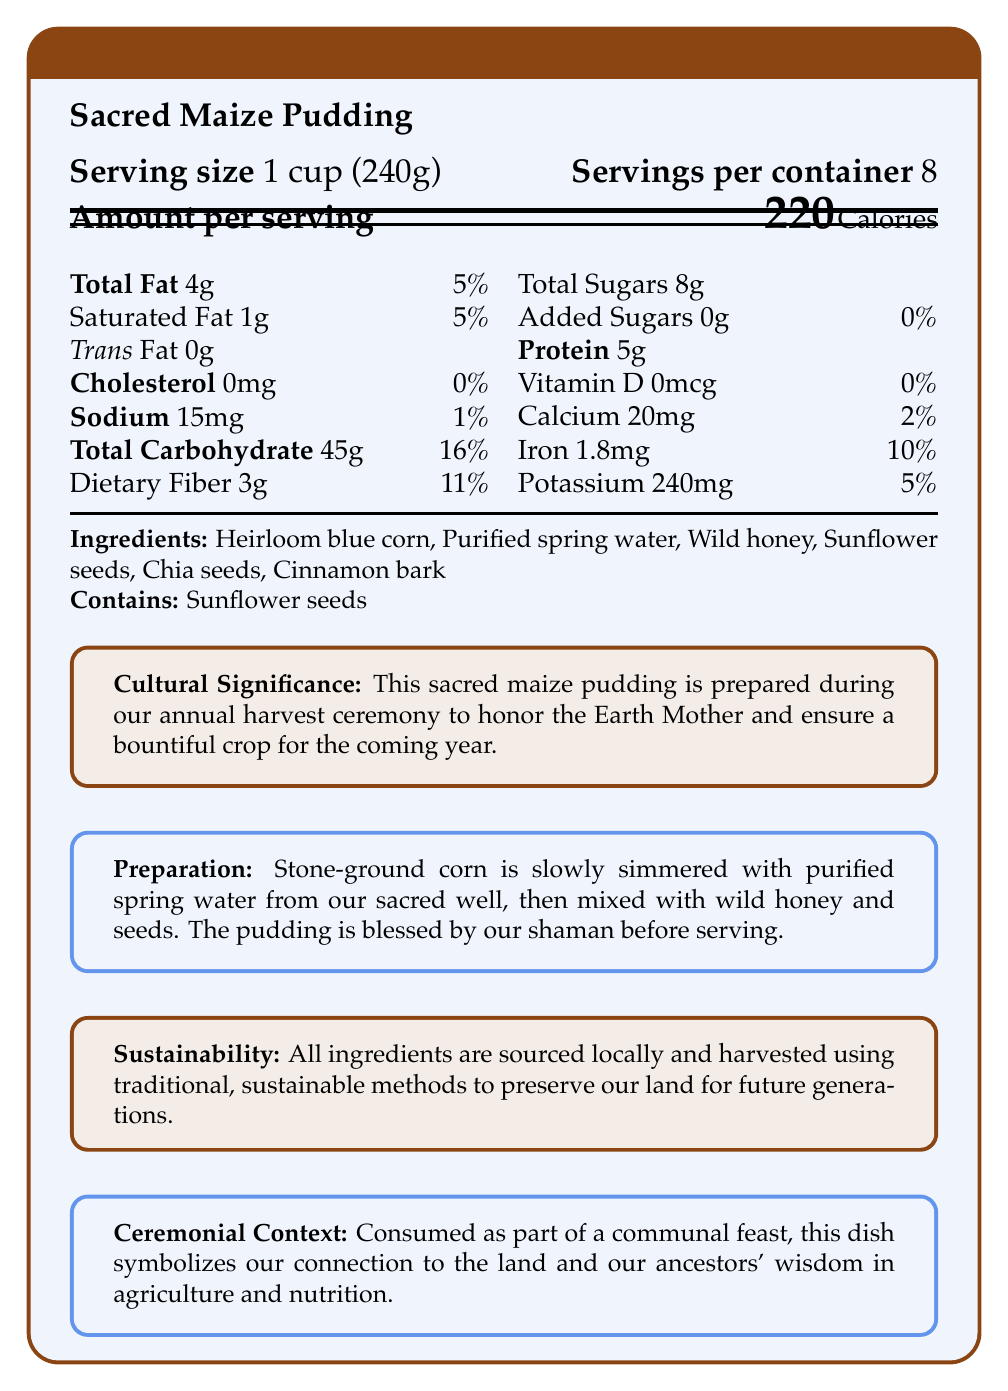what is the serving size for Sacred Maize Pudding? The document states the serving size directly as "1 cup (240g)".
Answer: 1 cup (240g) how many calories are in one serving? The document specifies "220 Calories" as the amount per serving.
Answer: 220 what is the percent daily value of dietary fiber in one serving? The document lists dietary fiber with a daily value of 11%.
Answer: 11% how much calcium is in one serving of Sacred Maize Pudding? The document provides the amount of calcium as "20mg".
Answer: 20mg what is the main carbohydrate source listed in the ingredients? The first ingredient listed is Heirloom blue corn, which is the main carbohydrate source.
Answer: Heirloom blue corn which of the following is not included in the ingredients? A. Chia seeds B. Cinnamon bark C. Almonds The ingredients list does not include almonds.
Answer: C how much protein is in one serving? A. 4g B. 5g C. 6g D. 7g The document states that one serving contains "5g" of protein.
Answer: B does the product contain any added sugars? The document mentions "Added Sugars 0g \hfill 0%" indicating no added sugars.
Answer: No does the Sacred Maize Pudding contain any common allergens? The document states "Contains: Sunflower seeds," which can be an allergen.
Answer: Yes describe the main idea of the document The document outlines the nutritional facts, ingredients, allergen information, the cultural and ceremonial importance of the dish, and how it's prepared and sourced sustainably.
Answer: The document provides detailed nutritional information for the Sacred Maize Pudding, including its serving size, calorie content, and amounts of various nutrients. It also highlights the cultural significance, ceremonial context, and sustainable sourcing methods of the dish. how many servings are in each container? The document specifies "Servings per container" as 8.
Answer: 8 how much iron is in one serving and what percentage of the daily value does it represent? The document states that one serving contains 1.8mg of iron and this represents 10% of the daily value.
Answer: 1.8mg, 10% can this document provide the exact amount of Vitamin C in Sacred Maize Pudding? The document does not mention Vitamin C at all, so the exact amount cannot be determined from the available information.
Answer: Not enough information how is the Sacred Maize Pudding prepared? The document provides this information in the "Preparation" section.
Answer: Stone-ground corn is slowly simmered with purified spring water from our sacred well, then mixed with wild honey and seeds. The pudding is blessed by our shaman before serving. what is the significance of the dish mentioned in the document? The document mentions this in the "Cultural Significance" section.
Answer: This sacred maize pudding is prepared during our annual harvest ceremony to honor the Earth Mother and ensure a bountiful crop for the coming year. what percentage of the daily value of total fat does one serving provide? A. 3% B. 4% C. 5% D. 6% The document lists total fat content as 4g, contributing 5% to the daily value.
Answer: C 